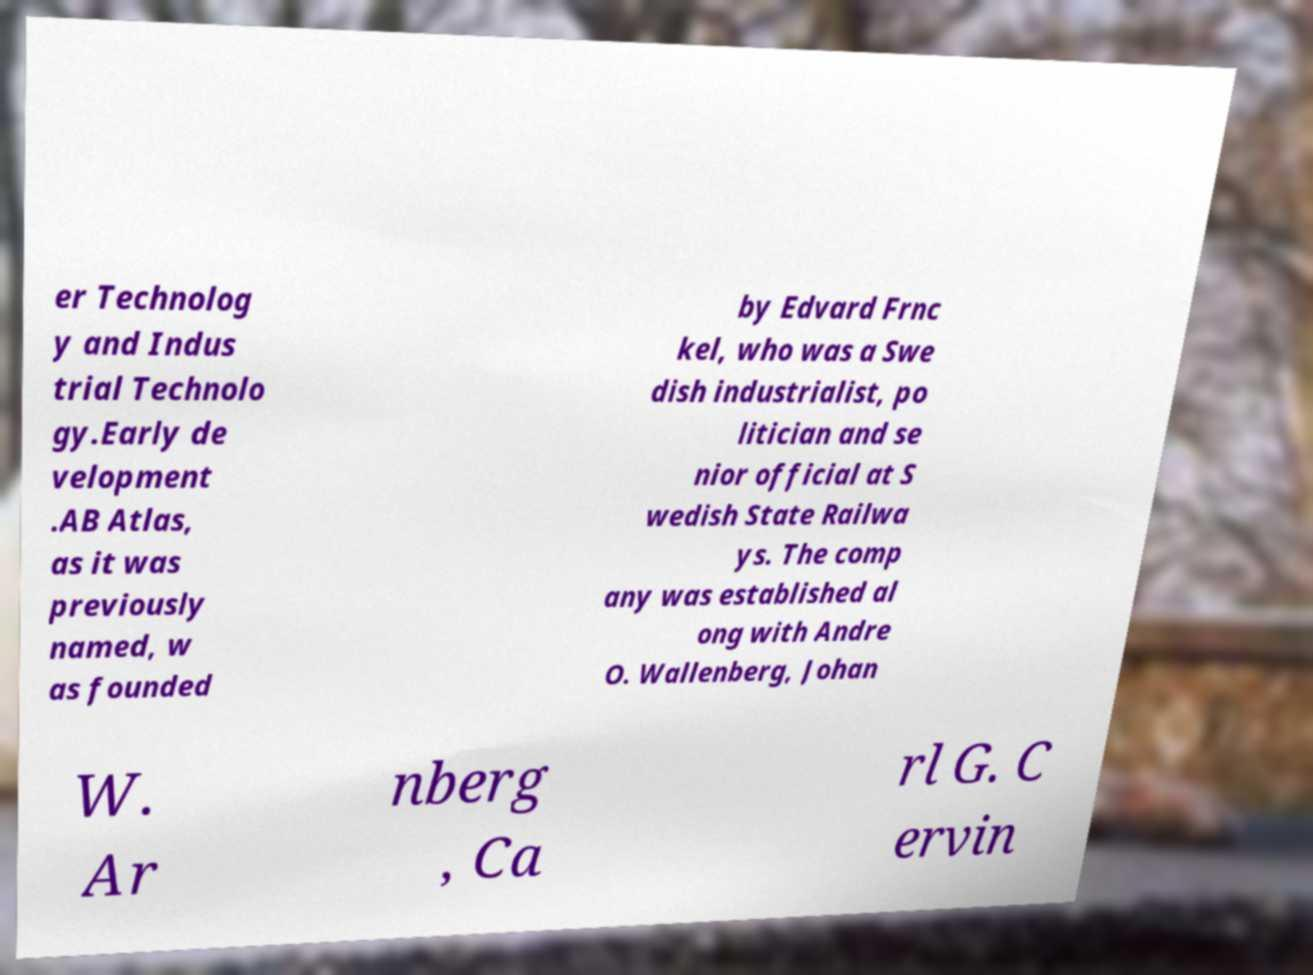What messages or text are displayed in this image? I need them in a readable, typed format. er Technolog y and Indus trial Technolo gy.Early de velopment .AB Atlas, as it was previously named, w as founded by Edvard Frnc kel, who was a Swe dish industrialist, po litician and se nior official at S wedish State Railwa ys. The comp any was established al ong with Andre O. Wallenberg, Johan W. Ar nberg , Ca rl G. C ervin 